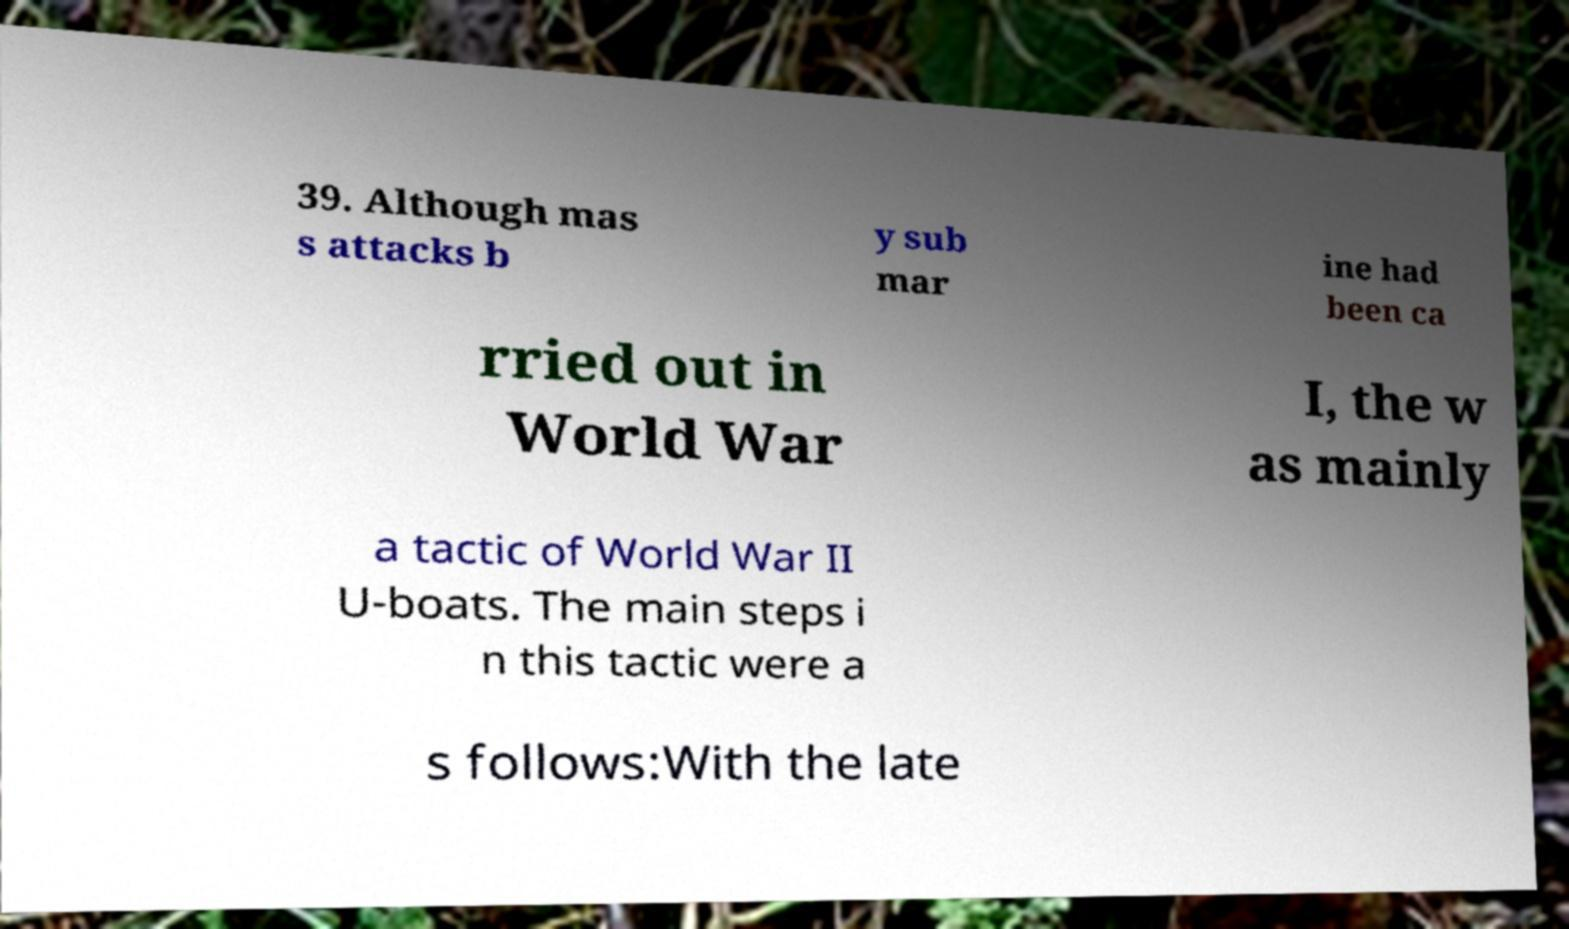Could you assist in decoding the text presented in this image and type it out clearly? 39. Although mas s attacks b y sub mar ine had been ca rried out in World War I, the w as mainly a tactic of World War II U-boats. The main steps i n this tactic were a s follows:With the late 